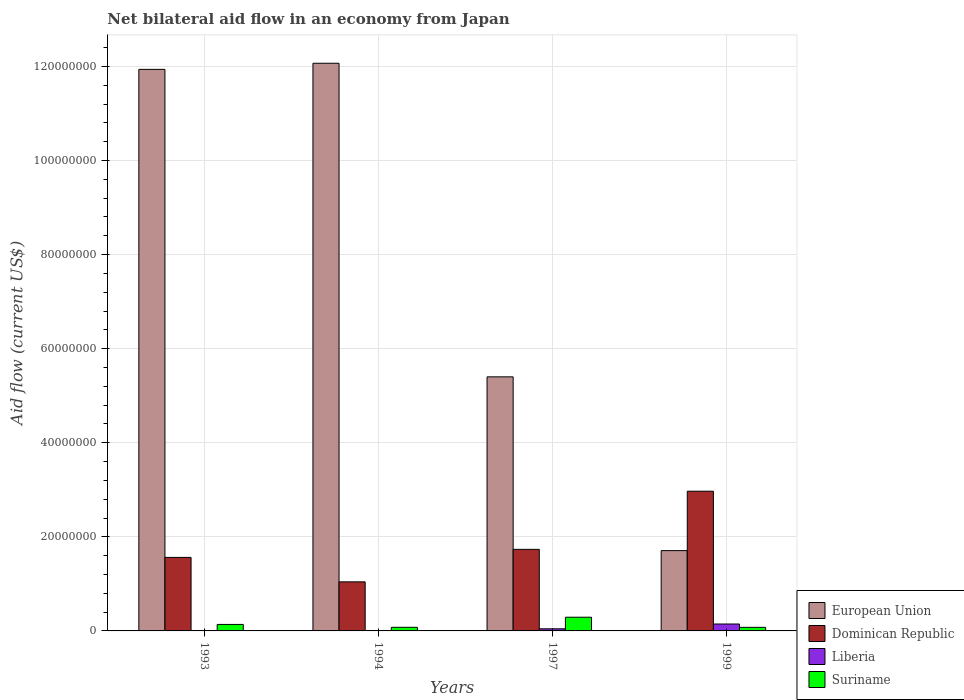Are the number of bars per tick equal to the number of legend labels?
Offer a very short reply. Yes. Are the number of bars on each tick of the X-axis equal?
Your answer should be compact. Yes. How many bars are there on the 1st tick from the left?
Give a very brief answer. 4. What is the label of the 1st group of bars from the left?
Keep it short and to the point. 1993. What is the net bilateral aid flow in Suriname in 1997?
Ensure brevity in your answer.  2.91e+06. Across all years, what is the maximum net bilateral aid flow in Dominican Republic?
Your answer should be compact. 2.97e+07. In which year was the net bilateral aid flow in European Union maximum?
Offer a terse response. 1994. In which year was the net bilateral aid flow in European Union minimum?
Your answer should be compact. 1999. What is the total net bilateral aid flow in Suriname in the graph?
Provide a short and direct response. 5.82e+06. What is the difference between the net bilateral aid flow in Suriname in 1993 and that in 1999?
Your response must be concise. 6.20e+05. What is the difference between the net bilateral aid flow in Dominican Republic in 1999 and the net bilateral aid flow in Liberia in 1994?
Offer a terse response. 2.97e+07. What is the average net bilateral aid flow in European Union per year?
Ensure brevity in your answer.  7.78e+07. In the year 1999, what is the difference between the net bilateral aid flow in Suriname and net bilateral aid flow in Liberia?
Make the answer very short. -7.10e+05. In how many years, is the net bilateral aid flow in Liberia greater than 60000000 US$?
Your answer should be very brief. 0. What is the ratio of the net bilateral aid flow in Dominican Republic in 1993 to that in 1994?
Your answer should be compact. 1.5. What is the difference between the highest and the second highest net bilateral aid flow in Dominican Republic?
Your answer should be very brief. 1.24e+07. What is the difference between the highest and the lowest net bilateral aid flow in Liberia?
Your answer should be compact. 1.44e+06. Is the sum of the net bilateral aid flow in Suriname in 1993 and 1999 greater than the maximum net bilateral aid flow in Dominican Republic across all years?
Offer a very short reply. No. What does the 2nd bar from the left in 1993 represents?
Ensure brevity in your answer.  Dominican Republic. What does the 1st bar from the right in 1999 represents?
Provide a short and direct response. Suriname. Are all the bars in the graph horizontal?
Provide a succinct answer. No. Does the graph contain any zero values?
Your response must be concise. No. Does the graph contain grids?
Provide a succinct answer. Yes. Where does the legend appear in the graph?
Give a very brief answer. Bottom right. What is the title of the graph?
Offer a very short reply. Net bilateral aid flow in an economy from Japan. What is the label or title of the Y-axis?
Ensure brevity in your answer.  Aid flow (current US$). What is the Aid flow (current US$) in European Union in 1993?
Your answer should be compact. 1.19e+08. What is the Aid flow (current US$) of Dominican Republic in 1993?
Ensure brevity in your answer.  1.56e+07. What is the Aid flow (current US$) of Suriname in 1993?
Ensure brevity in your answer.  1.38e+06. What is the Aid flow (current US$) of European Union in 1994?
Give a very brief answer. 1.21e+08. What is the Aid flow (current US$) of Dominican Republic in 1994?
Offer a terse response. 1.04e+07. What is the Aid flow (current US$) of Liberia in 1994?
Provide a short and direct response. 3.00e+04. What is the Aid flow (current US$) of Suriname in 1994?
Provide a succinct answer. 7.70e+05. What is the Aid flow (current US$) in European Union in 1997?
Your answer should be compact. 5.40e+07. What is the Aid flow (current US$) of Dominican Republic in 1997?
Your response must be concise. 1.73e+07. What is the Aid flow (current US$) of Liberia in 1997?
Offer a very short reply. 4.50e+05. What is the Aid flow (current US$) of Suriname in 1997?
Provide a short and direct response. 2.91e+06. What is the Aid flow (current US$) of European Union in 1999?
Provide a short and direct response. 1.71e+07. What is the Aid flow (current US$) in Dominican Republic in 1999?
Offer a terse response. 2.97e+07. What is the Aid flow (current US$) in Liberia in 1999?
Your response must be concise. 1.47e+06. What is the Aid flow (current US$) of Suriname in 1999?
Provide a succinct answer. 7.60e+05. Across all years, what is the maximum Aid flow (current US$) of European Union?
Ensure brevity in your answer.  1.21e+08. Across all years, what is the maximum Aid flow (current US$) of Dominican Republic?
Provide a succinct answer. 2.97e+07. Across all years, what is the maximum Aid flow (current US$) of Liberia?
Your answer should be very brief. 1.47e+06. Across all years, what is the maximum Aid flow (current US$) in Suriname?
Make the answer very short. 2.91e+06. Across all years, what is the minimum Aid flow (current US$) in European Union?
Provide a succinct answer. 1.71e+07. Across all years, what is the minimum Aid flow (current US$) in Dominican Republic?
Your answer should be compact. 1.04e+07. Across all years, what is the minimum Aid flow (current US$) in Suriname?
Ensure brevity in your answer.  7.60e+05. What is the total Aid flow (current US$) of European Union in the graph?
Your answer should be very brief. 3.11e+08. What is the total Aid flow (current US$) in Dominican Republic in the graph?
Make the answer very short. 7.31e+07. What is the total Aid flow (current US$) in Liberia in the graph?
Make the answer very short. 2.01e+06. What is the total Aid flow (current US$) of Suriname in the graph?
Offer a very short reply. 5.82e+06. What is the difference between the Aid flow (current US$) in European Union in 1993 and that in 1994?
Offer a terse response. -1.30e+06. What is the difference between the Aid flow (current US$) in Dominican Republic in 1993 and that in 1994?
Make the answer very short. 5.20e+06. What is the difference between the Aid flow (current US$) of European Union in 1993 and that in 1997?
Provide a short and direct response. 6.54e+07. What is the difference between the Aid flow (current US$) of Dominican Republic in 1993 and that in 1997?
Give a very brief answer. -1.71e+06. What is the difference between the Aid flow (current US$) of Liberia in 1993 and that in 1997?
Make the answer very short. -3.90e+05. What is the difference between the Aid flow (current US$) in Suriname in 1993 and that in 1997?
Provide a short and direct response. -1.53e+06. What is the difference between the Aid flow (current US$) of European Union in 1993 and that in 1999?
Give a very brief answer. 1.02e+08. What is the difference between the Aid flow (current US$) of Dominican Republic in 1993 and that in 1999?
Offer a terse response. -1.41e+07. What is the difference between the Aid flow (current US$) in Liberia in 1993 and that in 1999?
Your answer should be very brief. -1.41e+06. What is the difference between the Aid flow (current US$) in Suriname in 1993 and that in 1999?
Your response must be concise. 6.20e+05. What is the difference between the Aid flow (current US$) in European Union in 1994 and that in 1997?
Ensure brevity in your answer.  6.67e+07. What is the difference between the Aid flow (current US$) in Dominican Republic in 1994 and that in 1997?
Your answer should be very brief. -6.91e+06. What is the difference between the Aid flow (current US$) in Liberia in 1994 and that in 1997?
Provide a succinct answer. -4.20e+05. What is the difference between the Aid flow (current US$) in Suriname in 1994 and that in 1997?
Give a very brief answer. -2.14e+06. What is the difference between the Aid flow (current US$) in European Union in 1994 and that in 1999?
Your answer should be compact. 1.04e+08. What is the difference between the Aid flow (current US$) in Dominican Republic in 1994 and that in 1999?
Your answer should be compact. -1.93e+07. What is the difference between the Aid flow (current US$) of Liberia in 1994 and that in 1999?
Your answer should be compact. -1.44e+06. What is the difference between the Aid flow (current US$) of Suriname in 1994 and that in 1999?
Offer a very short reply. 10000. What is the difference between the Aid flow (current US$) of European Union in 1997 and that in 1999?
Make the answer very short. 3.69e+07. What is the difference between the Aid flow (current US$) of Dominican Republic in 1997 and that in 1999?
Your answer should be very brief. -1.24e+07. What is the difference between the Aid flow (current US$) of Liberia in 1997 and that in 1999?
Ensure brevity in your answer.  -1.02e+06. What is the difference between the Aid flow (current US$) in Suriname in 1997 and that in 1999?
Keep it short and to the point. 2.15e+06. What is the difference between the Aid flow (current US$) in European Union in 1993 and the Aid flow (current US$) in Dominican Republic in 1994?
Make the answer very short. 1.09e+08. What is the difference between the Aid flow (current US$) of European Union in 1993 and the Aid flow (current US$) of Liberia in 1994?
Provide a short and direct response. 1.19e+08. What is the difference between the Aid flow (current US$) of European Union in 1993 and the Aid flow (current US$) of Suriname in 1994?
Your answer should be compact. 1.19e+08. What is the difference between the Aid flow (current US$) in Dominican Republic in 1993 and the Aid flow (current US$) in Liberia in 1994?
Your answer should be compact. 1.56e+07. What is the difference between the Aid flow (current US$) of Dominican Republic in 1993 and the Aid flow (current US$) of Suriname in 1994?
Keep it short and to the point. 1.49e+07. What is the difference between the Aid flow (current US$) of Liberia in 1993 and the Aid flow (current US$) of Suriname in 1994?
Provide a succinct answer. -7.10e+05. What is the difference between the Aid flow (current US$) of European Union in 1993 and the Aid flow (current US$) of Dominican Republic in 1997?
Give a very brief answer. 1.02e+08. What is the difference between the Aid flow (current US$) in European Union in 1993 and the Aid flow (current US$) in Liberia in 1997?
Give a very brief answer. 1.19e+08. What is the difference between the Aid flow (current US$) in European Union in 1993 and the Aid flow (current US$) in Suriname in 1997?
Provide a short and direct response. 1.16e+08. What is the difference between the Aid flow (current US$) in Dominican Republic in 1993 and the Aid flow (current US$) in Liberia in 1997?
Keep it short and to the point. 1.52e+07. What is the difference between the Aid flow (current US$) of Dominican Republic in 1993 and the Aid flow (current US$) of Suriname in 1997?
Your answer should be very brief. 1.27e+07. What is the difference between the Aid flow (current US$) in Liberia in 1993 and the Aid flow (current US$) in Suriname in 1997?
Give a very brief answer. -2.85e+06. What is the difference between the Aid flow (current US$) in European Union in 1993 and the Aid flow (current US$) in Dominican Republic in 1999?
Give a very brief answer. 8.97e+07. What is the difference between the Aid flow (current US$) of European Union in 1993 and the Aid flow (current US$) of Liberia in 1999?
Make the answer very short. 1.18e+08. What is the difference between the Aid flow (current US$) in European Union in 1993 and the Aid flow (current US$) in Suriname in 1999?
Offer a terse response. 1.19e+08. What is the difference between the Aid flow (current US$) of Dominican Republic in 1993 and the Aid flow (current US$) of Liberia in 1999?
Provide a succinct answer. 1.42e+07. What is the difference between the Aid flow (current US$) of Dominican Republic in 1993 and the Aid flow (current US$) of Suriname in 1999?
Keep it short and to the point. 1.49e+07. What is the difference between the Aid flow (current US$) in Liberia in 1993 and the Aid flow (current US$) in Suriname in 1999?
Your response must be concise. -7.00e+05. What is the difference between the Aid flow (current US$) of European Union in 1994 and the Aid flow (current US$) of Dominican Republic in 1997?
Offer a very short reply. 1.03e+08. What is the difference between the Aid flow (current US$) of European Union in 1994 and the Aid flow (current US$) of Liberia in 1997?
Your answer should be compact. 1.20e+08. What is the difference between the Aid flow (current US$) of European Union in 1994 and the Aid flow (current US$) of Suriname in 1997?
Provide a succinct answer. 1.18e+08. What is the difference between the Aid flow (current US$) of Dominican Republic in 1994 and the Aid flow (current US$) of Liberia in 1997?
Make the answer very short. 9.98e+06. What is the difference between the Aid flow (current US$) of Dominican Republic in 1994 and the Aid flow (current US$) of Suriname in 1997?
Give a very brief answer. 7.52e+06. What is the difference between the Aid flow (current US$) in Liberia in 1994 and the Aid flow (current US$) in Suriname in 1997?
Your answer should be compact. -2.88e+06. What is the difference between the Aid flow (current US$) in European Union in 1994 and the Aid flow (current US$) in Dominican Republic in 1999?
Ensure brevity in your answer.  9.10e+07. What is the difference between the Aid flow (current US$) in European Union in 1994 and the Aid flow (current US$) in Liberia in 1999?
Offer a terse response. 1.19e+08. What is the difference between the Aid flow (current US$) in European Union in 1994 and the Aid flow (current US$) in Suriname in 1999?
Offer a very short reply. 1.20e+08. What is the difference between the Aid flow (current US$) of Dominican Republic in 1994 and the Aid flow (current US$) of Liberia in 1999?
Ensure brevity in your answer.  8.96e+06. What is the difference between the Aid flow (current US$) in Dominican Republic in 1994 and the Aid flow (current US$) in Suriname in 1999?
Your answer should be compact. 9.67e+06. What is the difference between the Aid flow (current US$) in Liberia in 1994 and the Aid flow (current US$) in Suriname in 1999?
Offer a very short reply. -7.30e+05. What is the difference between the Aid flow (current US$) in European Union in 1997 and the Aid flow (current US$) in Dominican Republic in 1999?
Provide a short and direct response. 2.43e+07. What is the difference between the Aid flow (current US$) of European Union in 1997 and the Aid flow (current US$) of Liberia in 1999?
Offer a very short reply. 5.25e+07. What is the difference between the Aid flow (current US$) of European Union in 1997 and the Aid flow (current US$) of Suriname in 1999?
Provide a short and direct response. 5.32e+07. What is the difference between the Aid flow (current US$) of Dominican Republic in 1997 and the Aid flow (current US$) of Liberia in 1999?
Your answer should be compact. 1.59e+07. What is the difference between the Aid flow (current US$) in Dominican Republic in 1997 and the Aid flow (current US$) in Suriname in 1999?
Provide a succinct answer. 1.66e+07. What is the difference between the Aid flow (current US$) in Liberia in 1997 and the Aid flow (current US$) in Suriname in 1999?
Give a very brief answer. -3.10e+05. What is the average Aid flow (current US$) in European Union per year?
Provide a succinct answer. 7.78e+07. What is the average Aid flow (current US$) of Dominican Republic per year?
Offer a terse response. 1.83e+07. What is the average Aid flow (current US$) in Liberia per year?
Your answer should be very brief. 5.02e+05. What is the average Aid flow (current US$) in Suriname per year?
Your answer should be compact. 1.46e+06. In the year 1993, what is the difference between the Aid flow (current US$) in European Union and Aid flow (current US$) in Dominican Republic?
Give a very brief answer. 1.04e+08. In the year 1993, what is the difference between the Aid flow (current US$) of European Union and Aid flow (current US$) of Liberia?
Your response must be concise. 1.19e+08. In the year 1993, what is the difference between the Aid flow (current US$) in European Union and Aid flow (current US$) in Suriname?
Give a very brief answer. 1.18e+08. In the year 1993, what is the difference between the Aid flow (current US$) of Dominican Republic and Aid flow (current US$) of Liberia?
Your response must be concise. 1.56e+07. In the year 1993, what is the difference between the Aid flow (current US$) of Dominican Republic and Aid flow (current US$) of Suriname?
Your answer should be very brief. 1.42e+07. In the year 1993, what is the difference between the Aid flow (current US$) in Liberia and Aid flow (current US$) in Suriname?
Provide a short and direct response. -1.32e+06. In the year 1994, what is the difference between the Aid flow (current US$) in European Union and Aid flow (current US$) in Dominican Republic?
Give a very brief answer. 1.10e+08. In the year 1994, what is the difference between the Aid flow (current US$) in European Union and Aid flow (current US$) in Liberia?
Provide a short and direct response. 1.21e+08. In the year 1994, what is the difference between the Aid flow (current US$) in European Union and Aid flow (current US$) in Suriname?
Give a very brief answer. 1.20e+08. In the year 1994, what is the difference between the Aid flow (current US$) of Dominican Republic and Aid flow (current US$) of Liberia?
Provide a short and direct response. 1.04e+07. In the year 1994, what is the difference between the Aid flow (current US$) of Dominican Republic and Aid flow (current US$) of Suriname?
Your answer should be compact. 9.66e+06. In the year 1994, what is the difference between the Aid flow (current US$) in Liberia and Aid flow (current US$) in Suriname?
Keep it short and to the point. -7.40e+05. In the year 1997, what is the difference between the Aid flow (current US$) of European Union and Aid flow (current US$) of Dominican Republic?
Provide a short and direct response. 3.67e+07. In the year 1997, what is the difference between the Aid flow (current US$) of European Union and Aid flow (current US$) of Liberia?
Make the answer very short. 5.36e+07. In the year 1997, what is the difference between the Aid flow (current US$) of European Union and Aid flow (current US$) of Suriname?
Provide a succinct answer. 5.11e+07. In the year 1997, what is the difference between the Aid flow (current US$) in Dominican Republic and Aid flow (current US$) in Liberia?
Offer a terse response. 1.69e+07. In the year 1997, what is the difference between the Aid flow (current US$) of Dominican Republic and Aid flow (current US$) of Suriname?
Make the answer very short. 1.44e+07. In the year 1997, what is the difference between the Aid flow (current US$) of Liberia and Aid flow (current US$) of Suriname?
Give a very brief answer. -2.46e+06. In the year 1999, what is the difference between the Aid flow (current US$) of European Union and Aid flow (current US$) of Dominican Republic?
Your answer should be compact. -1.26e+07. In the year 1999, what is the difference between the Aid flow (current US$) in European Union and Aid flow (current US$) in Liberia?
Give a very brief answer. 1.56e+07. In the year 1999, what is the difference between the Aid flow (current US$) in European Union and Aid flow (current US$) in Suriname?
Make the answer very short. 1.63e+07. In the year 1999, what is the difference between the Aid flow (current US$) in Dominican Republic and Aid flow (current US$) in Liberia?
Your answer should be compact. 2.82e+07. In the year 1999, what is the difference between the Aid flow (current US$) in Dominican Republic and Aid flow (current US$) in Suriname?
Ensure brevity in your answer.  2.89e+07. In the year 1999, what is the difference between the Aid flow (current US$) of Liberia and Aid flow (current US$) of Suriname?
Make the answer very short. 7.10e+05. What is the ratio of the Aid flow (current US$) in Dominican Republic in 1993 to that in 1994?
Ensure brevity in your answer.  1.5. What is the ratio of the Aid flow (current US$) of Liberia in 1993 to that in 1994?
Offer a terse response. 2. What is the ratio of the Aid flow (current US$) of Suriname in 1993 to that in 1994?
Ensure brevity in your answer.  1.79. What is the ratio of the Aid flow (current US$) of European Union in 1993 to that in 1997?
Provide a succinct answer. 2.21. What is the ratio of the Aid flow (current US$) of Dominican Republic in 1993 to that in 1997?
Keep it short and to the point. 0.9. What is the ratio of the Aid flow (current US$) of Liberia in 1993 to that in 1997?
Ensure brevity in your answer.  0.13. What is the ratio of the Aid flow (current US$) of Suriname in 1993 to that in 1997?
Provide a succinct answer. 0.47. What is the ratio of the Aid flow (current US$) of European Union in 1993 to that in 1999?
Give a very brief answer. 6.99. What is the ratio of the Aid flow (current US$) in Dominican Republic in 1993 to that in 1999?
Provide a short and direct response. 0.53. What is the ratio of the Aid flow (current US$) of Liberia in 1993 to that in 1999?
Keep it short and to the point. 0.04. What is the ratio of the Aid flow (current US$) of Suriname in 1993 to that in 1999?
Provide a succinct answer. 1.82. What is the ratio of the Aid flow (current US$) of European Union in 1994 to that in 1997?
Give a very brief answer. 2.23. What is the ratio of the Aid flow (current US$) in Dominican Republic in 1994 to that in 1997?
Your answer should be compact. 0.6. What is the ratio of the Aid flow (current US$) of Liberia in 1994 to that in 1997?
Keep it short and to the point. 0.07. What is the ratio of the Aid flow (current US$) of Suriname in 1994 to that in 1997?
Offer a very short reply. 0.26. What is the ratio of the Aid flow (current US$) in European Union in 1994 to that in 1999?
Provide a short and direct response. 7.07. What is the ratio of the Aid flow (current US$) of Dominican Republic in 1994 to that in 1999?
Provide a short and direct response. 0.35. What is the ratio of the Aid flow (current US$) in Liberia in 1994 to that in 1999?
Ensure brevity in your answer.  0.02. What is the ratio of the Aid flow (current US$) of Suriname in 1994 to that in 1999?
Give a very brief answer. 1.01. What is the ratio of the Aid flow (current US$) of European Union in 1997 to that in 1999?
Your answer should be very brief. 3.16. What is the ratio of the Aid flow (current US$) in Dominican Republic in 1997 to that in 1999?
Your answer should be very brief. 0.58. What is the ratio of the Aid flow (current US$) of Liberia in 1997 to that in 1999?
Provide a succinct answer. 0.31. What is the ratio of the Aid flow (current US$) of Suriname in 1997 to that in 1999?
Keep it short and to the point. 3.83. What is the difference between the highest and the second highest Aid flow (current US$) of European Union?
Your answer should be compact. 1.30e+06. What is the difference between the highest and the second highest Aid flow (current US$) of Dominican Republic?
Keep it short and to the point. 1.24e+07. What is the difference between the highest and the second highest Aid flow (current US$) of Liberia?
Keep it short and to the point. 1.02e+06. What is the difference between the highest and the second highest Aid flow (current US$) of Suriname?
Make the answer very short. 1.53e+06. What is the difference between the highest and the lowest Aid flow (current US$) in European Union?
Ensure brevity in your answer.  1.04e+08. What is the difference between the highest and the lowest Aid flow (current US$) in Dominican Republic?
Your answer should be very brief. 1.93e+07. What is the difference between the highest and the lowest Aid flow (current US$) in Liberia?
Offer a terse response. 1.44e+06. What is the difference between the highest and the lowest Aid flow (current US$) in Suriname?
Your answer should be compact. 2.15e+06. 